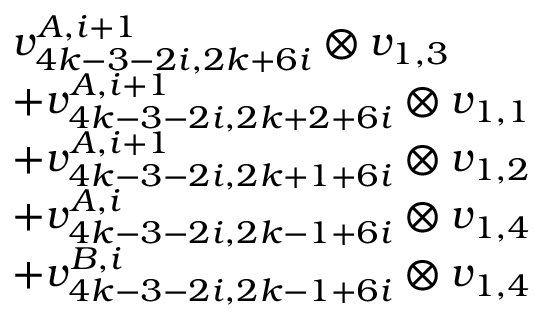Convert formula to latex. <formula><loc_0><loc_0><loc_500><loc_500>\begin{array} { r l } & { v _ { 4 k - 3 - 2 i , 2 k + 6 i } ^ { A , i + 1 } \otimes v _ { 1 , 3 } } \\ & { + v _ { 4 k - 3 - 2 i , 2 k + 2 + 6 i } ^ { A , i + 1 } \otimes v _ { 1 , 1 } } \\ & { + v _ { 4 k - 3 - 2 i , 2 k + 1 + 6 i } ^ { A , i + 1 } \otimes v _ { 1 , 2 } } \\ & { + v _ { 4 k - 3 - 2 i , 2 k - 1 + 6 i } ^ { A , i } \otimes v _ { 1 , 4 } } \\ & { + v _ { 4 k - 3 - 2 i , 2 k - 1 + 6 i } ^ { B , i } \otimes v _ { 1 , 4 } } \end{array}</formula> 